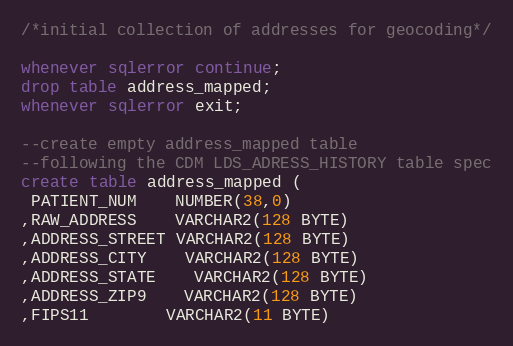<code> <loc_0><loc_0><loc_500><loc_500><_SQL_>/*initial collection of addresses for geocoding*/

whenever sqlerror continue;
drop table address_mapped;
whenever sqlerror exit;

--create empty address_mapped table
--following the CDM LDS_ADRESS_HISTORY table spec
create table address_mapped (
 PATIENT_NUM    NUMBER(38,0)   
,RAW_ADDRESS	VARCHAR2(128 BYTE)
,ADDRESS_STREET VARCHAR2(128 BYTE)
,ADDRESS_CITY	VARCHAR2(128 BYTE)
,ADDRESS_STATE	VARCHAR2(128 BYTE)
,ADDRESS_ZIP9	VARCHAR2(128 BYTE)
,FIPS11     	VARCHAR2(11 BYTE)</code> 